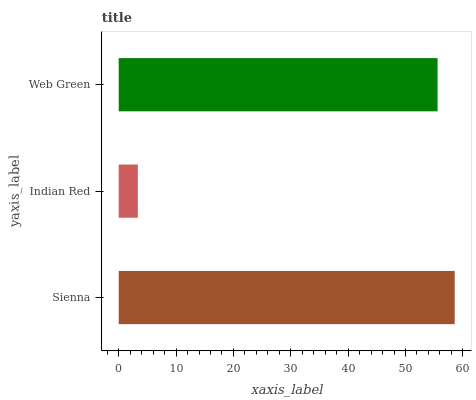Is Indian Red the minimum?
Answer yes or no. Yes. Is Sienna the maximum?
Answer yes or no. Yes. Is Web Green the minimum?
Answer yes or no. No. Is Web Green the maximum?
Answer yes or no. No. Is Web Green greater than Indian Red?
Answer yes or no. Yes. Is Indian Red less than Web Green?
Answer yes or no. Yes. Is Indian Red greater than Web Green?
Answer yes or no. No. Is Web Green less than Indian Red?
Answer yes or no. No. Is Web Green the high median?
Answer yes or no. Yes. Is Web Green the low median?
Answer yes or no. Yes. Is Sienna the high median?
Answer yes or no. No. Is Sienna the low median?
Answer yes or no. No. 